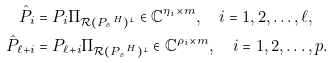Convert formula to latex. <formula><loc_0><loc_0><loc_500><loc_500>\hat { P } _ { i } & = P _ { i } \Pi _ { \mathcal { R } ( { P _ { s } } ^ { H } ) ^ { \perp } } \in \mathbb { C } ^ { \eta _ { i } \times m } , \quad i = 1 , 2 , \dots , \ell , \\ \hat { P } _ { \ell + i } & = P _ { \ell + i } \Pi _ { \mathcal { R } ( { P _ { s } } ^ { H } ) ^ { \perp } } \in \mathbb { C } ^ { \rho _ { i } \times m } , \quad i = 1 , 2 , \dots , p . \\</formula> 